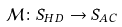<formula> <loc_0><loc_0><loc_500><loc_500>\mathcal { M } \colon S _ { H D } \rightarrow S _ { A C }</formula> 